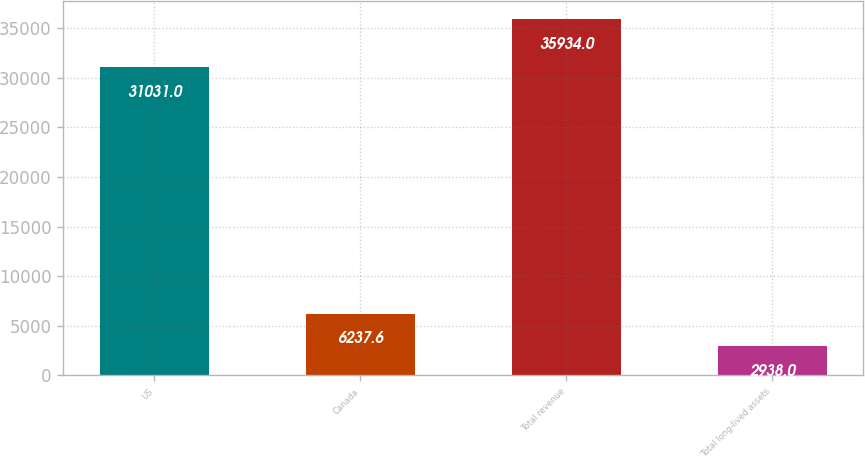Convert chart. <chart><loc_0><loc_0><loc_500><loc_500><bar_chart><fcel>US<fcel>Canada<fcel>Total revenue<fcel>Total long-lived assets<nl><fcel>31031<fcel>6237.6<fcel>35934<fcel>2938<nl></chart> 